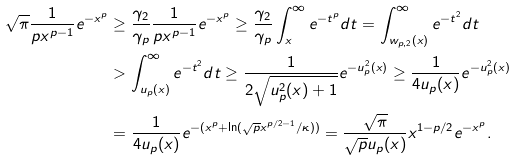<formula> <loc_0><loc_0><loc_500><loc_500>\sqrt { \pi } \frac { 1 } { p x ^ { p - 1 } } e ^ { - x ^ { p } } & \geq \frac { \gamma _ { 2 } } { \gamma _ { p } } \frac { 1 } { p x ^ { p - 1 } } e ^ { - x ^ { p } } \geq \frac { \gamma _ { 2 } } { \gamma _ { p } } \int _ { x } ^ { \infty } e ^ { - t ^ { p } } d t = \int _ { w _ { p , 2 } ( x ) } ^ { \infty } e ^ { - t ^ { 2 } } d t \\ & > \int _ { u _ { p } ( x ) } ^ { \infty } e ^ { - t ^ { 2 } } d t \geq \frac { 1 } { 2 \sqrt { u _ { p } ^ { 2 } ( x ) + 1 } } e ^ { - u _ { p } ^ { 2 } ( x ) } \geq \frac { 1 } { 4 u _ { p } ( x ) } e ^ { - u _ { p } ^ { 2 } ( x ) } \\ & = \frac { 1 } { 4 u _ { p } ( x ) } e ^ { - ( x ^ { p } + \ln ( \sqrt { p } x ^ { p / 2 - 1 } / \kappa ) ) } = \frac { \sqrt { \pi } } { \sqrt { p } u _ { p } ( x ) } x ^ { 1 - p / 2 } e ^ { - x ^ { p } } .</formula> 